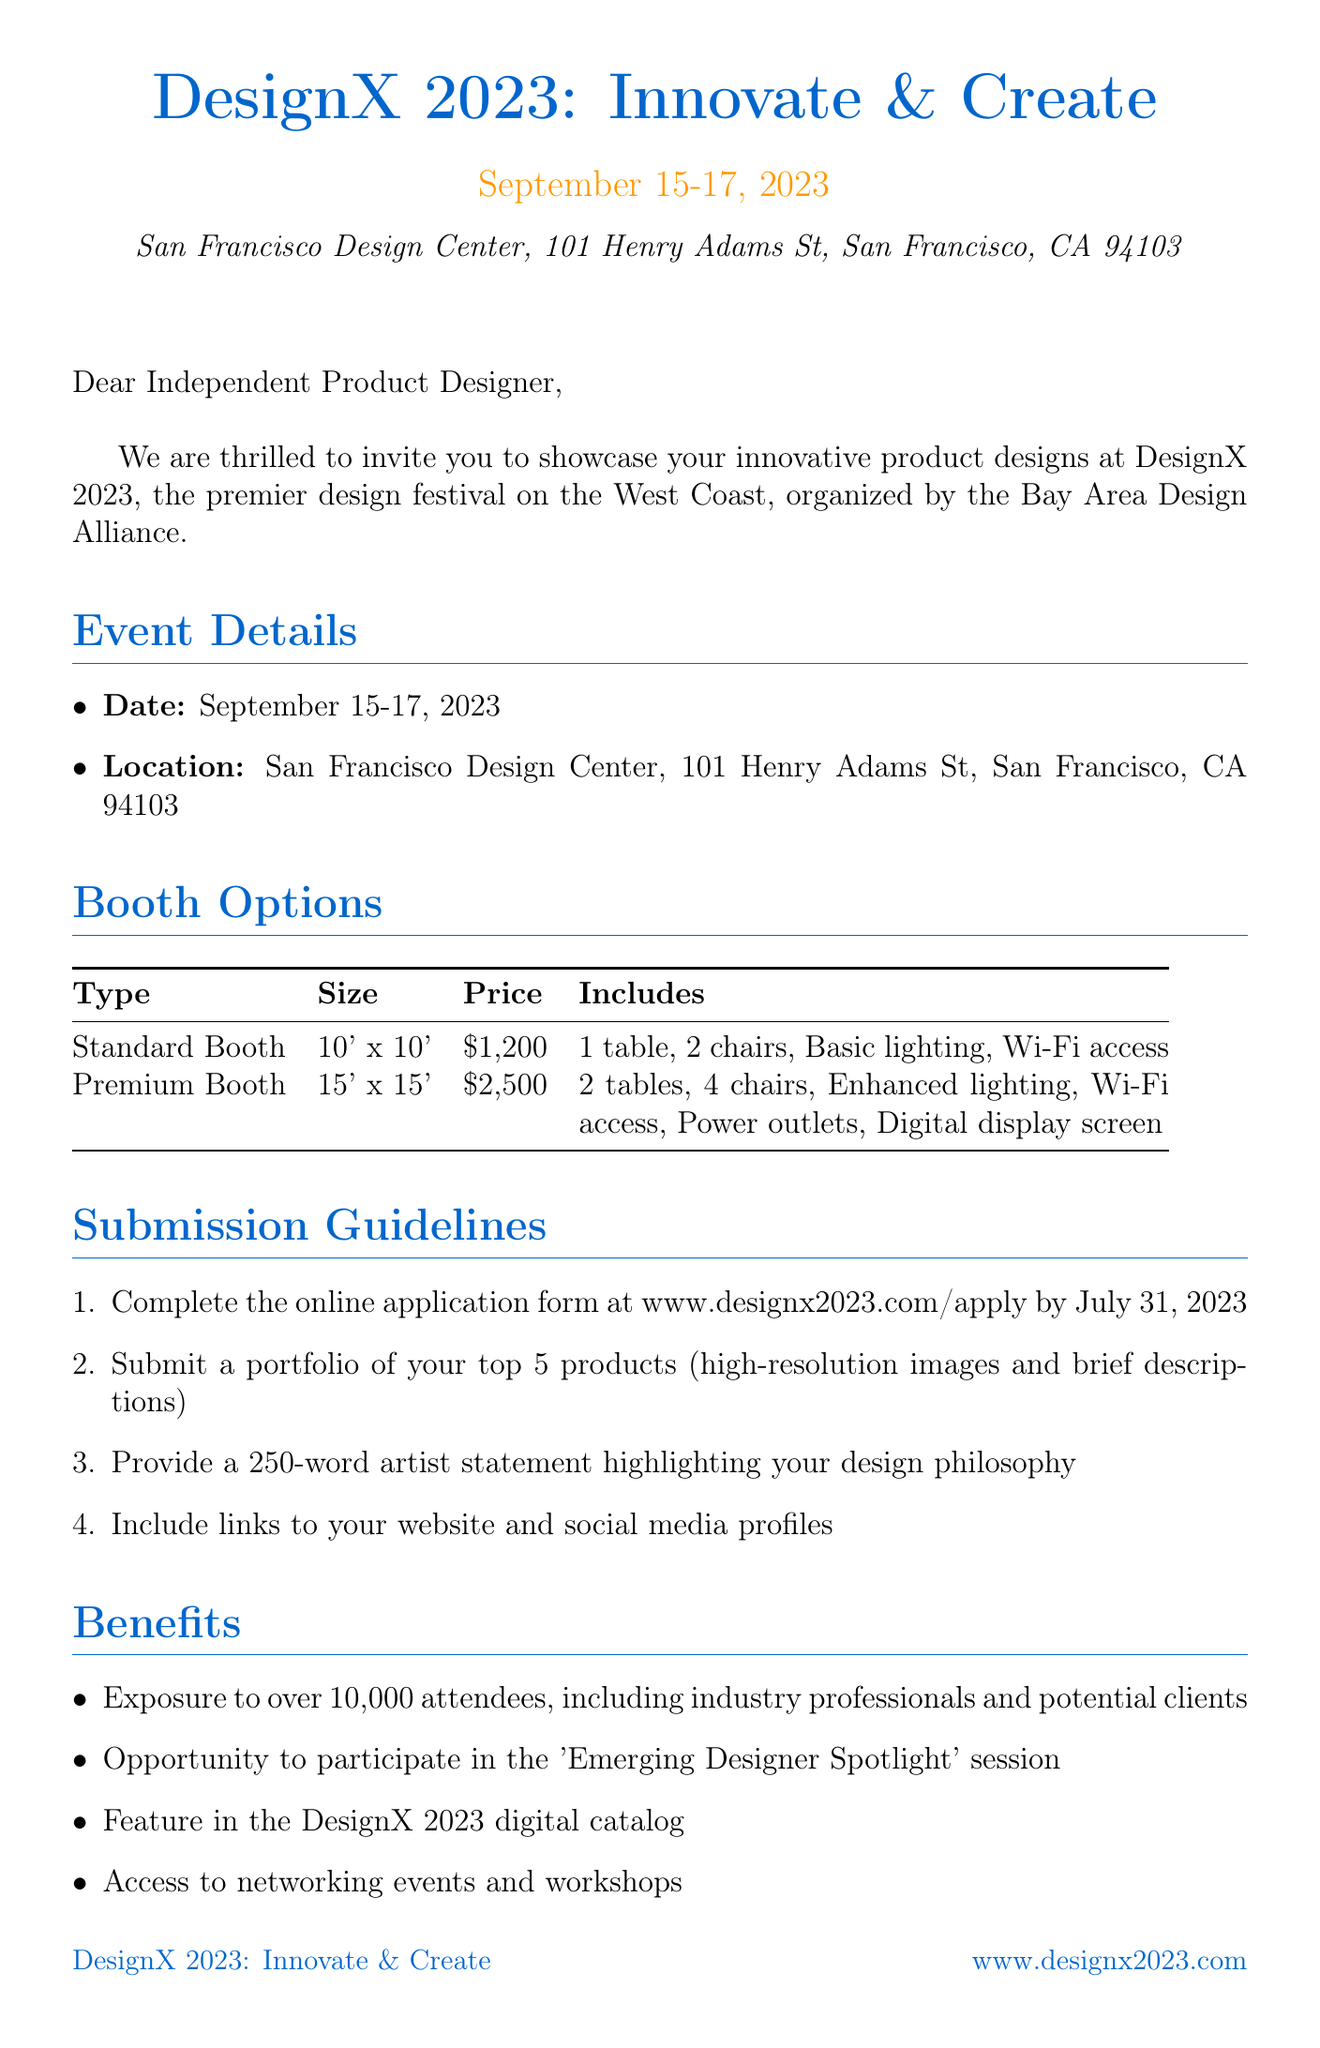What are the festival dates? The festival dates can be found in the event details section of the document, which specifies September 15-17, 2023.
Answer: September 15-17, 2023 Who is the organizer of the festival? The name of the organizer is provided in the introduction of the document, which states that it is the Bay Area Design Alliance.
Answer: Bay Area Design Alliance What is the price of a Premium Booth? The document lists the price of a Premium Booth in the booth options section, stating it is $2,500.
Answer: $2,500 What is the application deadline? The application deadline is found in the important dates section, which indicates it is July 31, 2023.
Answer: July 31, 2023 What benefit includes exposure to industry professionals? The document outlines several benefits, specifically mentioning exposure to over 10,000 attendees, which includes industry professionals and potential clients.
Answer: Exposure to over 10,000 attendees What are the minimum required submissions for the application? The submission guidelines note that a portfolio of top 5 products, high-resolution images, and brief descriptions is required among other documents.
Answer: Portfolio of top 5 products What is the contact person's email? The contact person's email is listed towards the end of the document, which is emily.chen@designx2023.com.
Answer: emily.chen@designx2023.com When is the setup day for the festival? The festival setup date can be found in the important dates section stating it is September 14, 2023.
Answer: September 14, 2023 What type of booth includes a digital display screen? The booth options section specifically mentions that the Premium Booth includes a digital display screen.
Answer: Premium Booth 